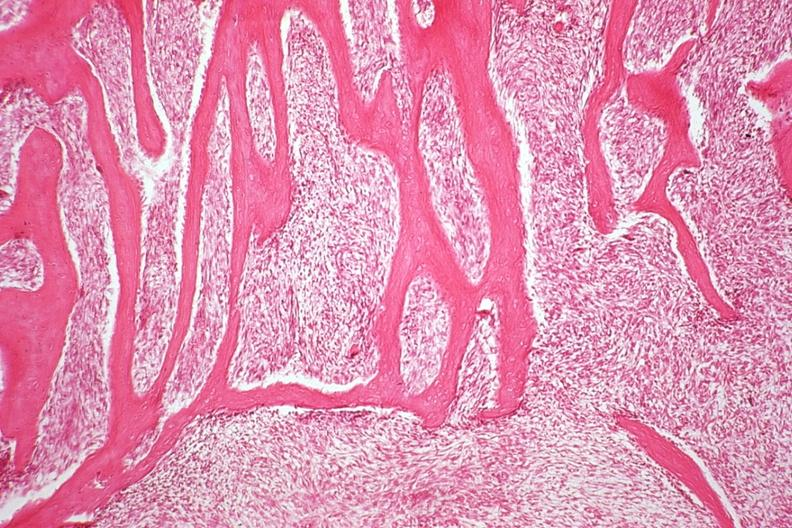s joints present?
Answer the question using a single word or phrase. Yes 